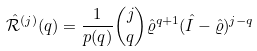<formula> <loc_0><loc_0><loc_500><loc_500>\hat { \mathcal { R } } ^ { ( j ) } ( q ) = \frac { 1 } { p ( q ) } \binom { j } { q } \hat { \varrho } ^ { q + 1 } ( \hat { I } - \hat { \varrho } ) ^ { j - q }</formula> 